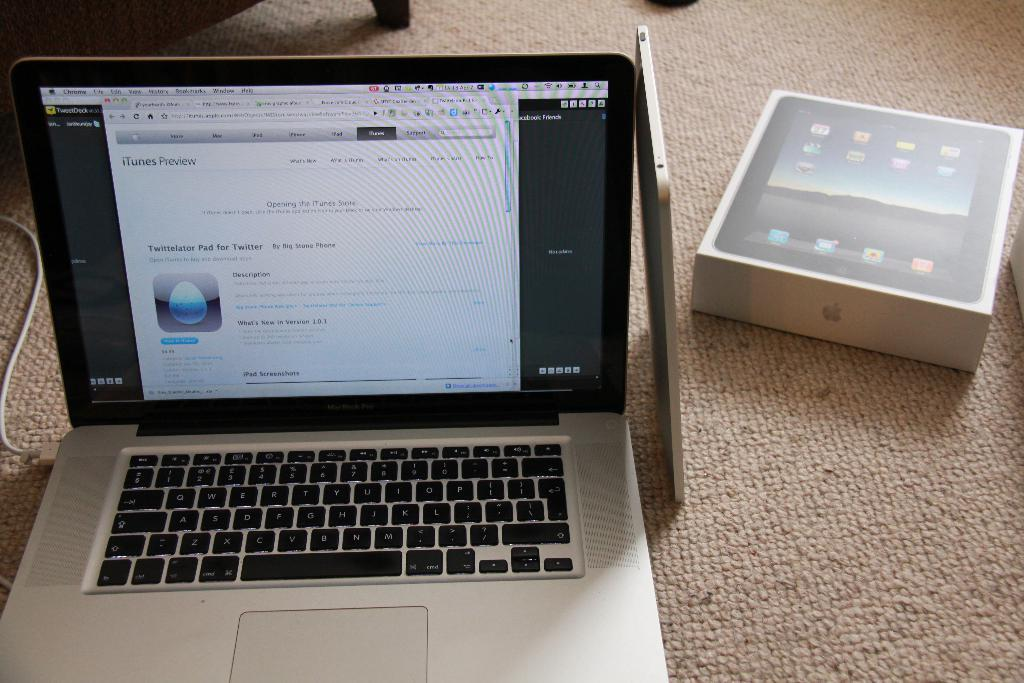<image>
Create a compact narrative representing the image presented. Macbook Pro laptop that shows iTunes Preview on the screen. 